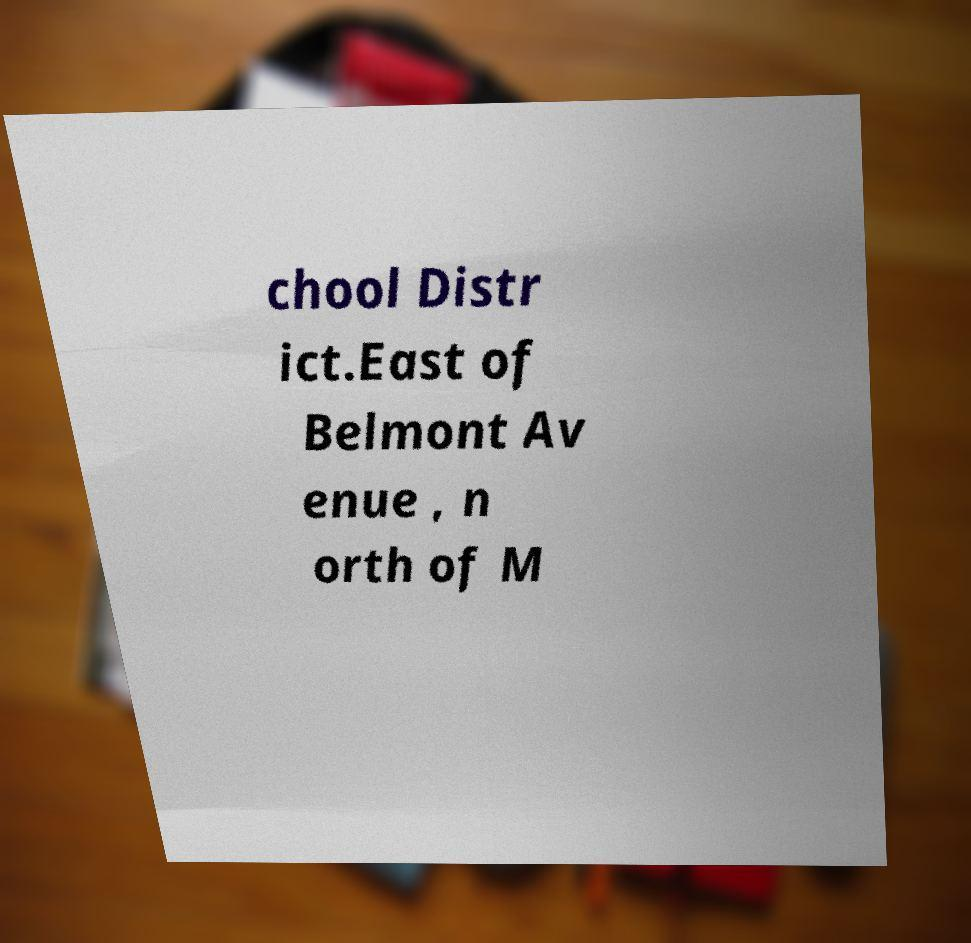Could you extract and type out the text from this image? chool Distr ict.East of Belmont Av enue , n orth of M 